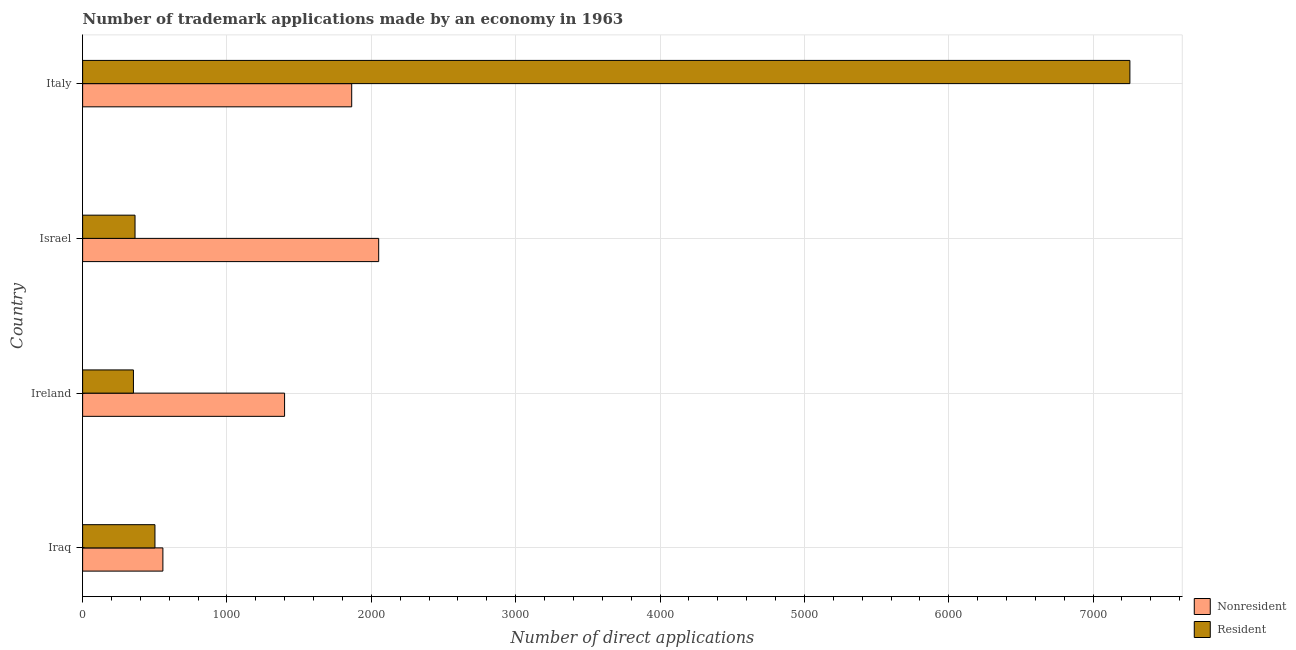How many different coloured bars are there?
Make the answer very short. 2. How many groups of bars are there?
Offer a terse response. 4. Are the number of bars per tick equal to the number of legend labels?
Give a very brief answer. Yes. How many bars are there on the 4th tick from the bottom?
Offer a terse response. 2. What is the label of the 3rd group of bars from the top?
Make the answer very short. Ireland. In how many cases, is the number of bars for a given country not equal to the number of legend labels?
Provide a succinct answer. 0. What is the number of trademark applications made by residents in Iraq?
Provide a short and direct response. 501. Across all countries, what is the maximum number of trademark applications made by residents?
Offer a very short reply. 7255. Across all countries, what is the minimum number of trademark applications made by residents?
Your response must be concise. 352. In which country was the number of trademark applications made by residents minimum?
Give a very brief answer. Ireland. What is the total number of trademark applications made by residents in the graph?
Keep it short and to the point. 8471. What is the difference between the number of trademark applications made by non residents in Ireland and that in Italy?
Your answer should be very brief. -465. What is the difference between the number of trademark applications made by residents in Ireland and the number of trademark applications made by non residents in Italy?
Ensure brevity in your answer.  -1512. What is the average number of trademark applications made by residents per country?
Your response must be concise. 2117.75. What is the difference between the number of trademark applications made by non residents and number of trademark applications made by residents in Italy?
Provide a short and direct response. -5391. In how many countries, is the number of trademark applications made by residents greater than 1600 ?
Your answer should be compact. 1. What is the ratio of the number of trademark applications made by residents in Israel to that in Italy?
Your answer should be compact. 0.05. Is the number of trademark applications made by residents in Israel less than that in Italy?
Provide a short and direct response. Yes. Is the difference between the number of trademark applications made by residents in Ireland and Italy greater than the difference between the number of trademark applications made by non residents in Ireland and Italy?
Your response must be concise. No. What is the difference between the highest and the second highest number of trademark applications made by residents?
Give a very brief answer. 6754. What is the difference between the highest and the lowest number of trademark applications made by non residents?
Give a very brief answer. 1495. In how many countries, is the number of trademark applications made by non residents greater than the average number of trademark applications made by non residents taken over all countries?
Provide a short and direct response. 2. Is the sum of the number of trademark applications made by non residents in Ireland and Israel greater than the maximum number of trademark applications made by residents across all countries?
Ensure brevity in your answer.  No. What does the 2nd bar from the top in Ireland represents?
Your answer should be very brief. Nonresident. What does the 2nd bar from the bottom in Israel represents?
Keep it short and to the point. Resident. Are all the bars in the graph horizontal?
Provide a short and direct response. Yes. How many countries are there in the graph?
Provide a short and direct response. 4. Are the values on the major ticks of X-axis written in scientific E-notation?
Give a very brief answer. No. Does the graph contain grids?
Make the answer very short. Yes. How are the legend labels stacked?
Your answer should be very brief. Vertical. What is the title of the graph?
Provide a succinct answer. Number of trademark applications made by an economy in 1963. Does "Non-residents" appear as one of the legend labels in the graph?
Your response must be concise. No. What is the label or title of the X-axis?
Keep it short and to the point. Number of direct applications. What is the Number of direct applications of Nonresident in Iraq?
Your answer should be compact. 556. What is the Number of direct applications in Resident in Iraq?
Offer a very short reply. 501. What is the Number of direct applications of Nonresident in Ireland?
Make the answer very short. 1399. What is the Number of direct applications of Resident in Ireland?
Provide a short and direct response. 352. What is the Number of direct applications of Nonresident in Israel?
Provide a succinct answer. 2051. What is the Number of direct applications of Resident in Israel?
Provide a succinct answer. 363. What is the Number of direct applications in Nonresident in Italy?
Keep it short and to the point. 1864. What is the Number of direct applications of Resident in Italy?
Your response must be concise. 7255. Across all countries, what is the maximum Number of direct applications of Nonresident?
Provide a short and direct response. 2051. Across all countries, what is the maximum Number of direct applications of Resident?
Give a very brief answer. 7255. Across all countries, what is the minimum Number of direct applications in Nonresident?
Provide a succinct answer. 556. Across all countries, what is the minimum Number of direct applications of Resident?
Your response must be concise. 352. What is the total Number of direct applications of Nonresident in the graph?
Make the answer very short. 5870. What is the total Number of direct applications in Resident in the graph?
Your answer should be very brief. 8471. What is the difference between the Number of direct applications in Nonresident in Iraq and that in Ireland?
Provide a short and direct response. -843. What is the difference between the Number of direct applications in Resident in Iraq and that in Ireland?
Your response must be concise. 149. What is the difference between the Number of direct applications of Nonresident in Iraq and that in Israel?
Your answer should be compact. -1495. What is the difference between the Number of direct applications in Resident in Iraq and that in Israel?
Offer a terse response. 138. What is the difference between the Number of direct applications of Nonresident in Iraq and that in Italy?
Make the answer very short. -1308. What is the difference between the Number of direct applications in Resident in Iraq and that in Italy?
Ensure brevity in your answer.  -6754. What is the difference between the Number of direct applications of Nonresident in Ireland and that in Israel?
Give a very brief answer. -652. What is the difference between the Number of direct applications of Resident in Ireland and that in Israel?
Your answer should be compact. -11. What is the difference between the Number of direct applications in Nonresident in Ireland and that in Italy?
Your response must be concise. -465. What is the difference between the Number of direct applications in Resident in Ireland and that in Italy?
Your response must be concise. -6903. What is the difference between the Number of direct applications in Nonresident in Israel and that in Italy?
Give a very brief answer. 187. What is the difference between the Number of direct applications in Resident in Israel and that in Italy?
Offer a very short reply. -6892. What is the difference between the Number of direct applications of Nonresident in Iraq and the Number of direct applications of Resident in Ireland?
Keep it short and to the point. 204. What is the difference between the Number of direct applications of Nonresident in Iraq and the Number of direct applications of Resident in Israel?
Give a very brief answer. 193. What is the difference between the Number of direct applications of Nonresident in Iraq and the Number of direct applications of Resident in Italy?
Offer a very short reply. -6699. What is the difference between the Number of direct applications of Nonresident in Ireland and the Number of direct applications of Resident in Israel?
Your answer should be very brief. 1036. What is the difference between the Number of direct applications of Nonresident in Ireland and the Number of direct applications of Resident in Italy?
Provide a succinct answer. -5856. What is the difference between the Number of direct applications of Nonresident in Israel and the Number of direct applications of Resident in Italy?
Your answer should be compact. -5204. What is the average Number of direct applications in Nonresident per country?
Your response must be concise. 1467.5. What is the average Number of direct applications of Resident per country?
Your response must be concise. 2117.75. What is the difference between the Number of direct applications in Nonresident and Number of direct applications in Resident in Ireland?
Provide a succinct answer. 1047. What is the difference between the Number of direct applications of Nonresident and Number of direct applications of Resident in Israel?
Offer a terse response. 1688. What is the difference between the Number of direct applications in Nonresident and Number of direct applications in Resident in Italy?
Your answer should be very brief. -5391. What is the ratio of the Number of direct applications in Nonresident in Iraq to that in Ireland?
Your answer should be compact. 0.4. What is the ratio of the Number of direct applications of Resident in Iraq to that in Ireland?
Offer a terse response. 1.42. What is the ratio of the Number of direct applications of Nonresident in Iraq to that in Israel?
Your answer should be very brief. 0.27. What is the ratio of the Number of direct applications in Resident in Iraq to that in Israel?
Provide a short and direct response. 1.38. What is the ratio of the Number of direct applications in Nonresident in Iraq to that in Italy?
Give a very brief answer. 0.3. What is the ratio of the Number of direct applications of Resident in Iraq to that in Italy?
Ensure brevity in your answer.  0.07. What is the ratio of the Number of direct applications in Nonresident in Ireland to that in Israel?
Ensure brevity in your answer.  0.68. What is the ratio of the Number of direct applications in Resident in Ireland to that in Israel?
Your answer should be very brief. 0.97. What is the ratio of the Number of direct applications of Nonresident in Ireland to that in Italy?
Your answer should be compact. 0.75. What is the ratio of the Number of direct applications in Resident in Ireland to that in Italy?
Make the answer very short. 0.05. What is the ratio of the Number of direct applications in Nonresident in Israel to that in Italy?
Ensure brevity in your answer.  1.1. What is the difference between the highest and the second highest Number of direct applications of Nonresident?
Provide a succinct answer. 187. What is the difference between the highest and the second highest Number of direct applications in Resident?
Your response must be concise. 6754. What is the difference between the highest and the lowest Number of direct applications in Nonresident?
Offer a terse response. 1495. What is the difference between the highest and the lowest Number of direct applications of Resident?
Your answer should be compact. 6903. 